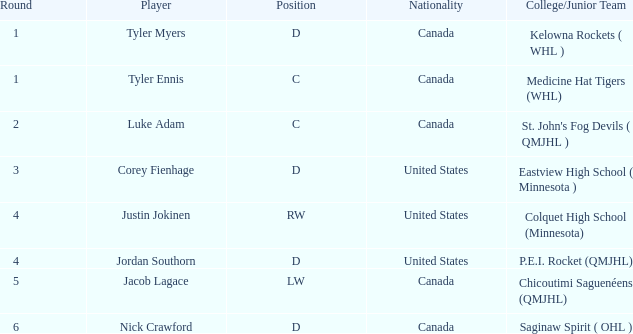What is the average round of the rw position player from the United States? 4.0. 